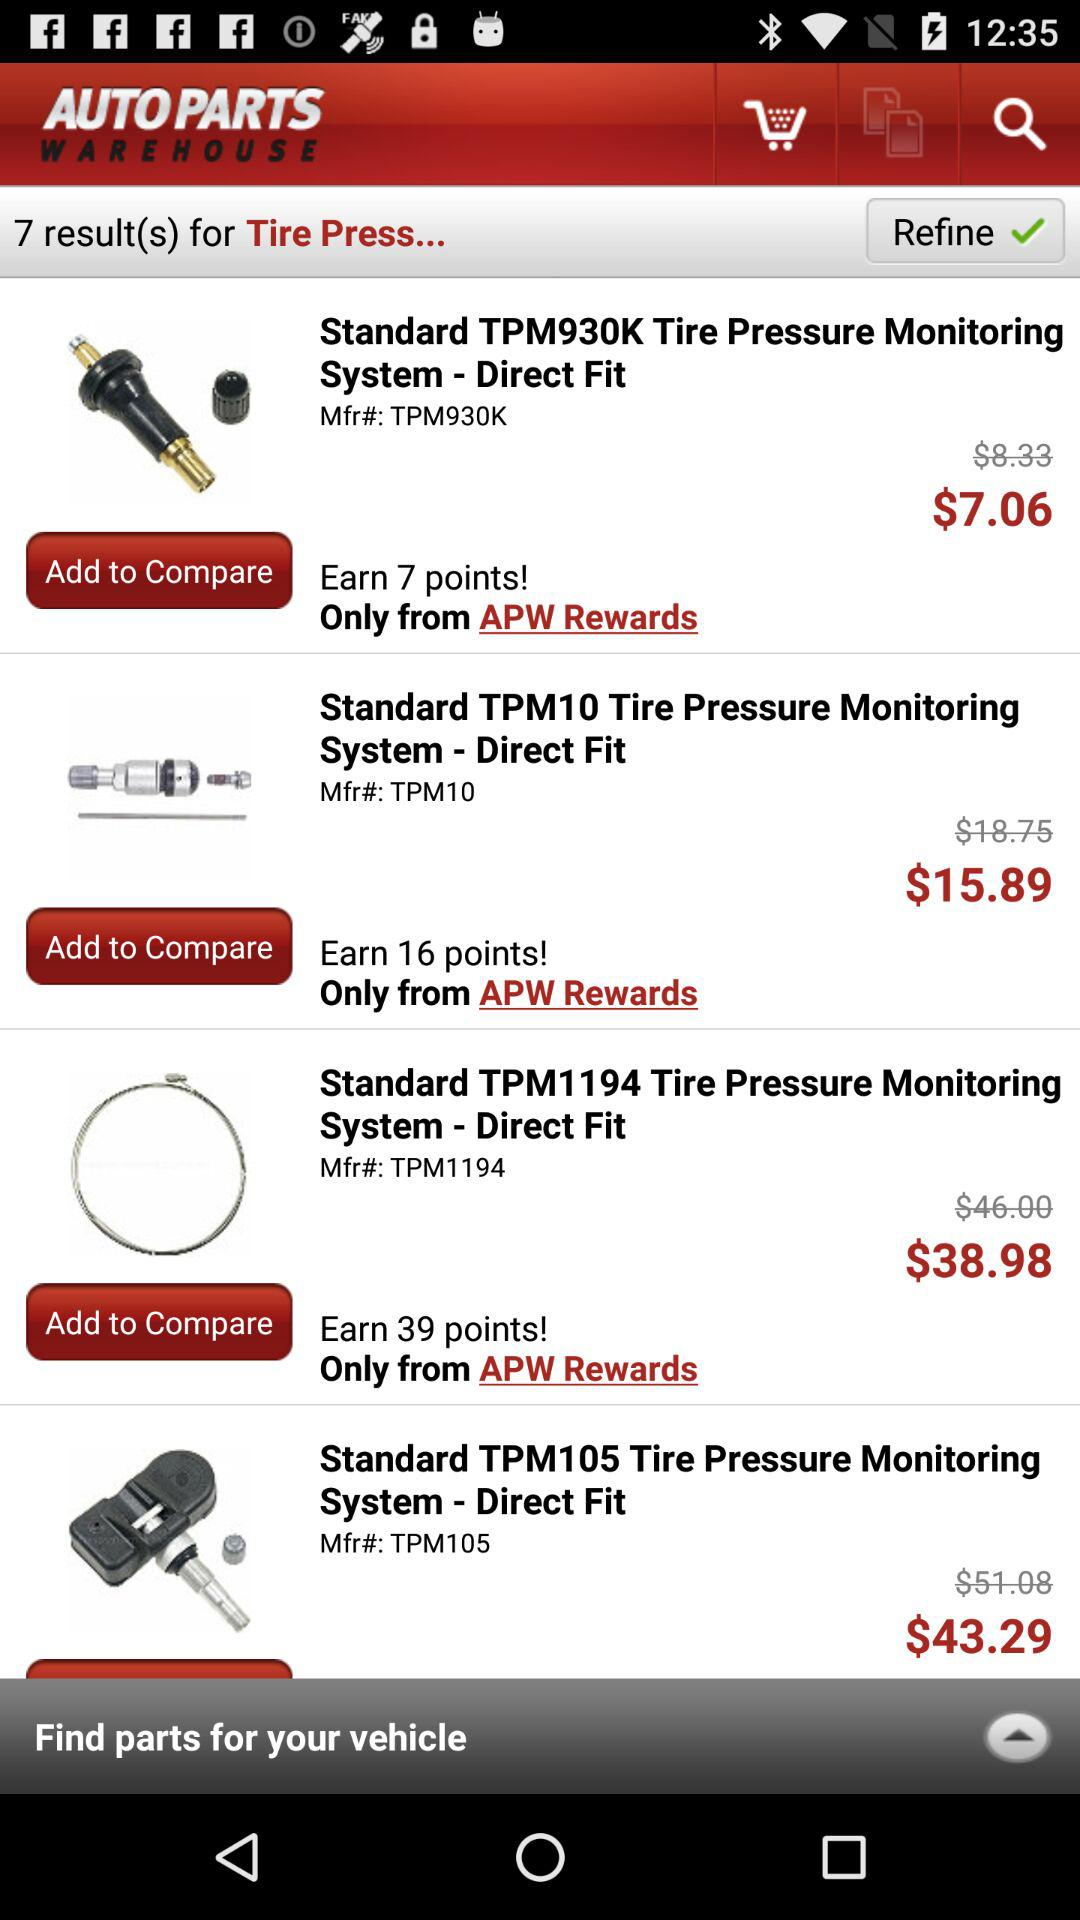What is the price of the standard TPM 105 tyre pressure monitoring system? The price is $43.29. 